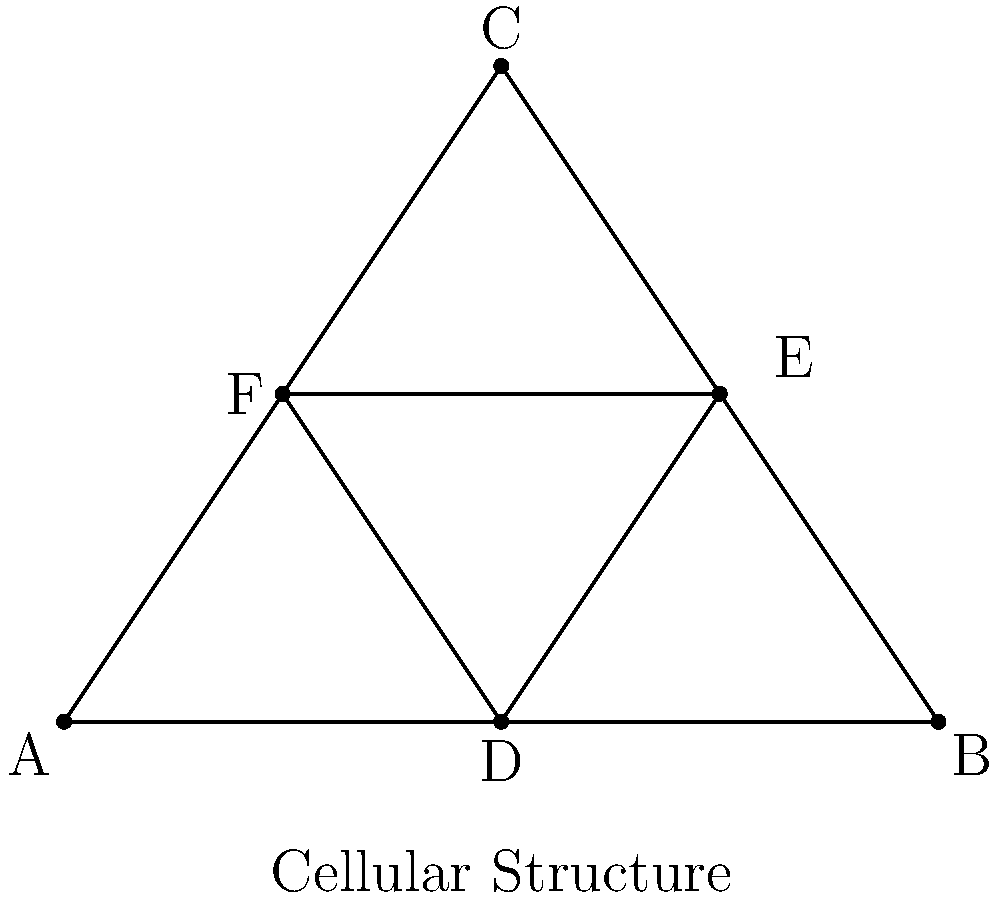In the study of cellular structures across various organisms, a triangular model is often used to represent the arrangement of proteins in cell membranes. Consider the triangle ABC in the figure, which represents such a cellular structure. If D, E, and F are the midpoints of the sides of triangle ABC, what is the ratio of the area of triangle DEF to the area of triangle ABC? How might this ratio relate to the efficiency of molecular transport across cell membranes? Let's approach this step-by-step:

1) First, we need to recall the Midpoint Theorem, which states that a line segment joining the midpoints of two sides of a triangle is parallel to the third side and half the length.

2) In our case, DE is parallel to AC and half its length, EF is parallel to BC and half its length, and FD is parallel to AB and half its length.

3) This means that triangle DEF is similar to triangle ABC, with each side of DEF being half the length of the corresponding side of ABC.

4) When two triangles are similar, the ratio of their areas is equal to the square of the ratio of their corresponding sides.

5) Let's call the ratio of the sides $r$. We know $r = \frac{1}{2}$.

6) The ratio of the areas will be $r^2 = (\frac{1}{2})^2 = \frac{1}{4}$.

7) Therefore, the area of triangle DEF is $\frac{1}{4}$ of the area of triangle ABC.

Relating this to cellular biology:
This 1:4 ratio could be interpreted in terms of molecular transport efficiency. The outer triangle ABC could represent the total surface area of a cell membrane, while the inner triangle DEF could represent the area of active transport sites. The ratio suggests that a cell can maintain efficient molecular transport with active sites covering only 25% of its surface area, allowing for energy conservation while still meeting the cell's needs.
Answer: $\frac{1}{4}$ 